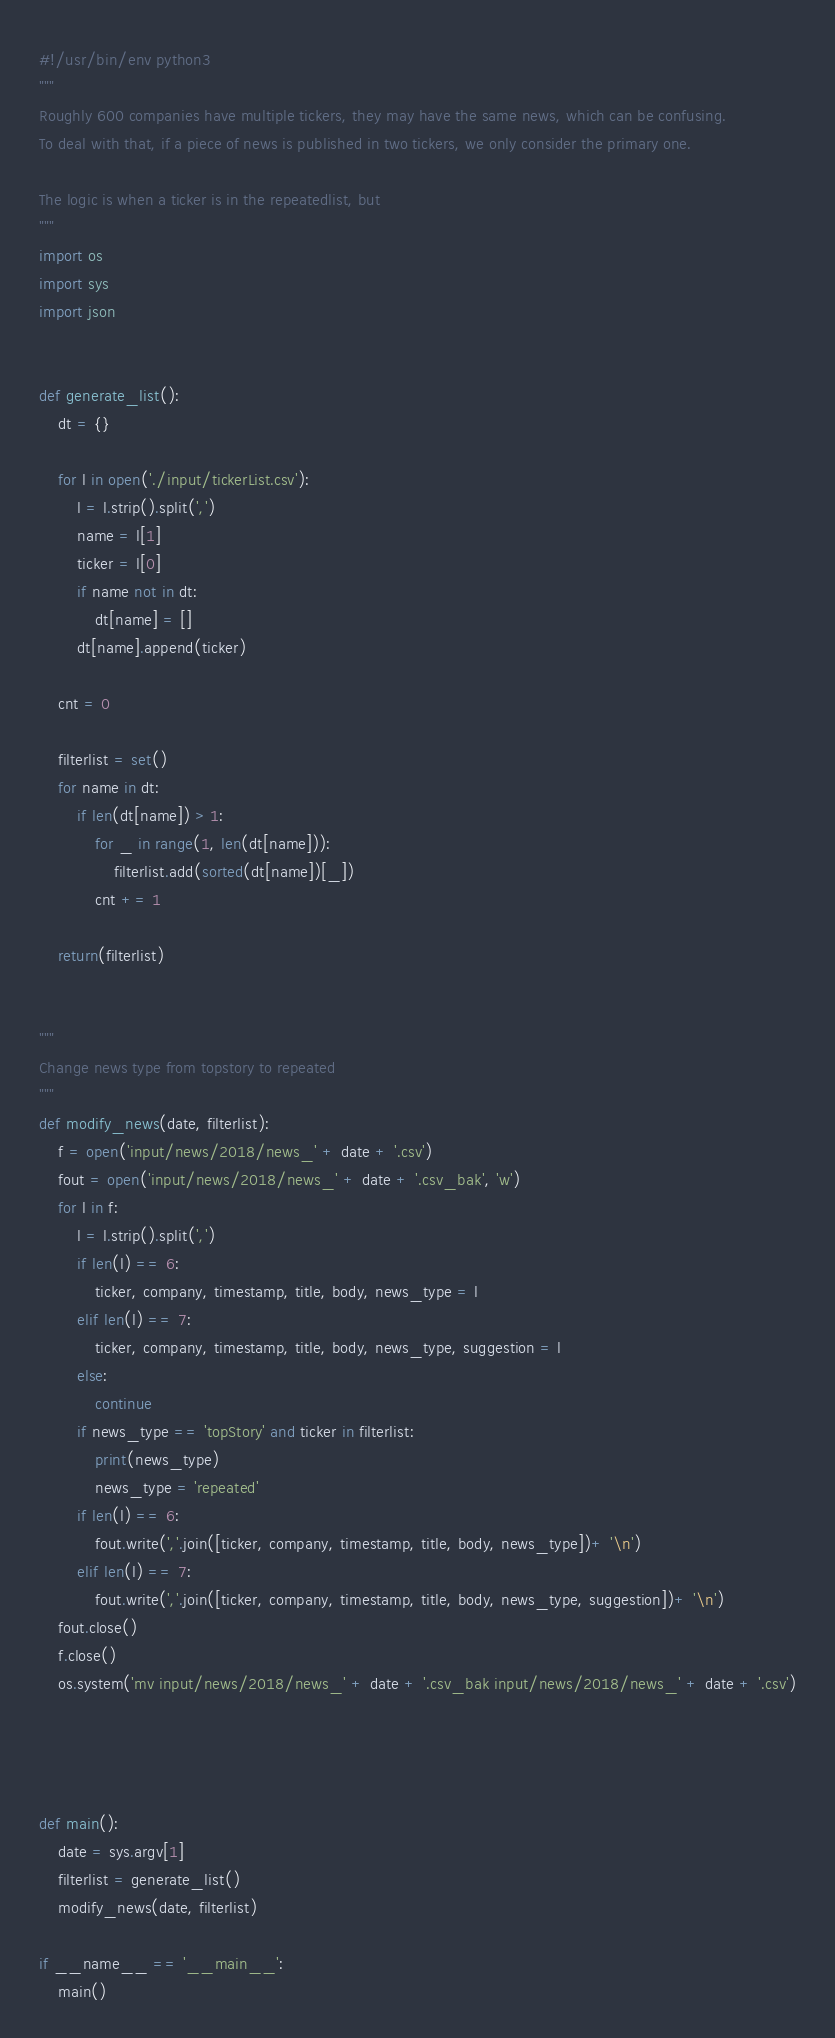<code> <loc_0><loc_0><loc_500><loc_500><_Python_>#!/usr/bin/env python3
"""
Roughly 600 companies have multiple tickers, they may have the same news, which can be confusing.
To deal with that, if a piece of news is published in two tickers, we only consider the primary one.

The logic is when a ticker is in the repeatedlist, but 
"""
import os
import sys
import json


def generate_list():
    dt = {}

    for l in open('./input/tickerList.csv'):
        l = l.strip().split(',')
        name = l[1]
        ticker = l[0]
        if name not in dt:
            dt[name] = []
        dt[name].append(ticker)

    cnt = 0

    filterlist = set()
    for name in dt:
        if len(dt[name]) > 1:
            for _ in range(1, len(dt[name])):
                filterlist.add(sorted(dt[name])[_])
            cnt += 1

    return(filterlist)


"""
Change news type from topstory to repeated
"""
def modify_news(date, filterlist):
    f = open('input/news/2018/news_' + date + '.csv')
    fout = open('input/news/2018/news_' + date + '.csv_bak', 'w')
    for l in f:
        l = l.strip().split(',')
        if len(l) == 6:
            ticker, company, timestamp, title, body, news_type = l
        elif len(l) == 7:
            ticker, company, timestamp, title, body, news_type, suggestion = l
        else:
            continue
        if news_type == 'topStory' and ticker in filterlist:
            print(news_type)
            news_type = 'repeated'
        if len(l) == 6:
            fout.write(','.join([ticker, company, timestamp, title, body, news_type])+ '\n')
        elif len(l) == 7:
            fout.write(','.join([ticker, company, timestamp, title, body, news_type, suggestion])+ '\n')
    fout.close()
    f.close()
    os.system('mv input/news/2018/news_' + date + '.csv_bak input/news/2018/news_' + date + '.csv')

    


def main():
    date = sys.argv[1]
    filterlist = generate_list()
    modify_news(date, filterlist)

if __name__ == '__main__':
    main()
</code> 